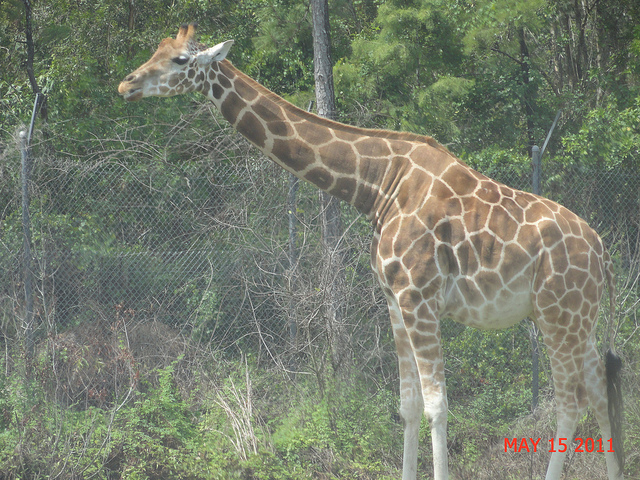Please extract the text content from this image. MAY 15 2011 